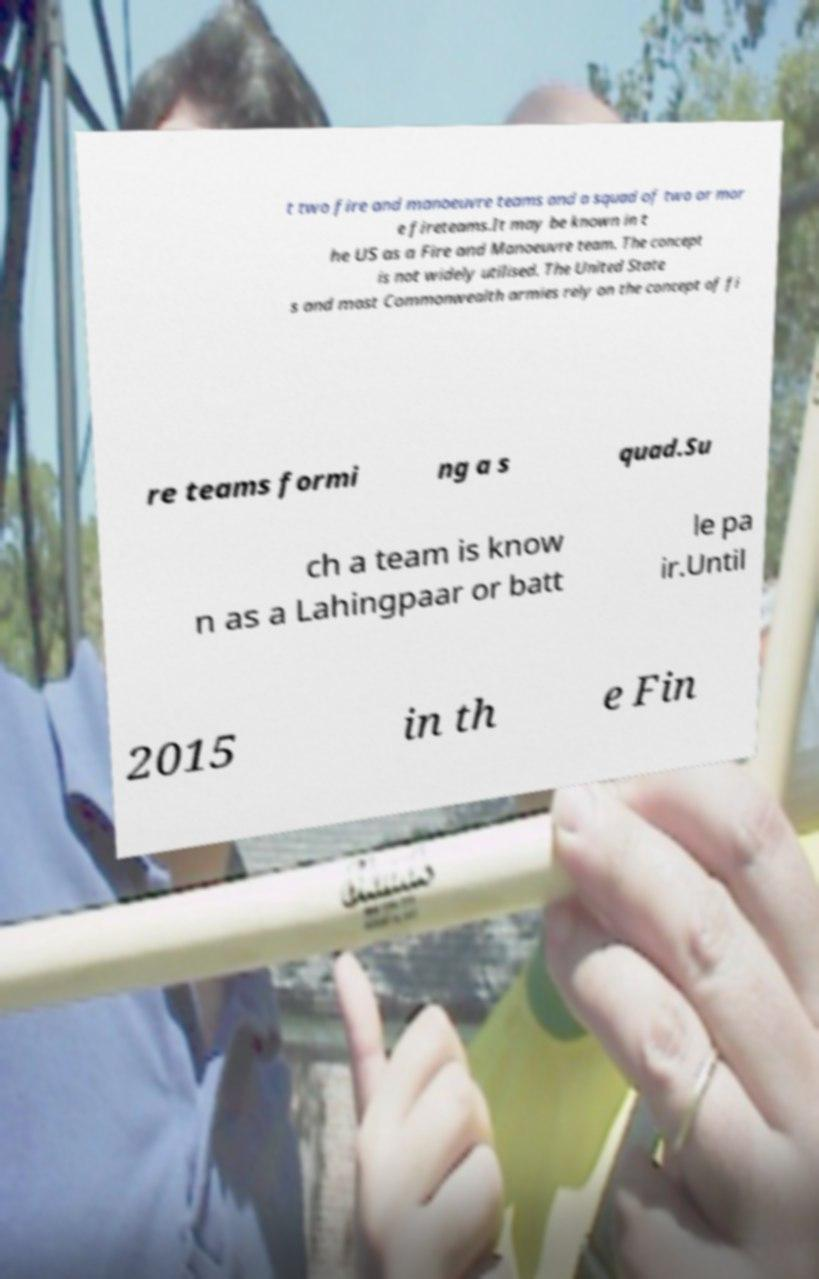There's text embedded in this image that I need extracted. Can you transcribe it verbatim? t two fire and manoeuvre teams and a squad of two or mor e fireteams.It may be known in t he US as a Fire and Manoeuvre team. The concept is not widely utilised. The United State s and most Commonwealth armies rely on the concept of fi re teams formi ng a s quad.Su ch a team is know n as a Lahingpaar or batt le pa ir.Until 2015 in th e Fin 